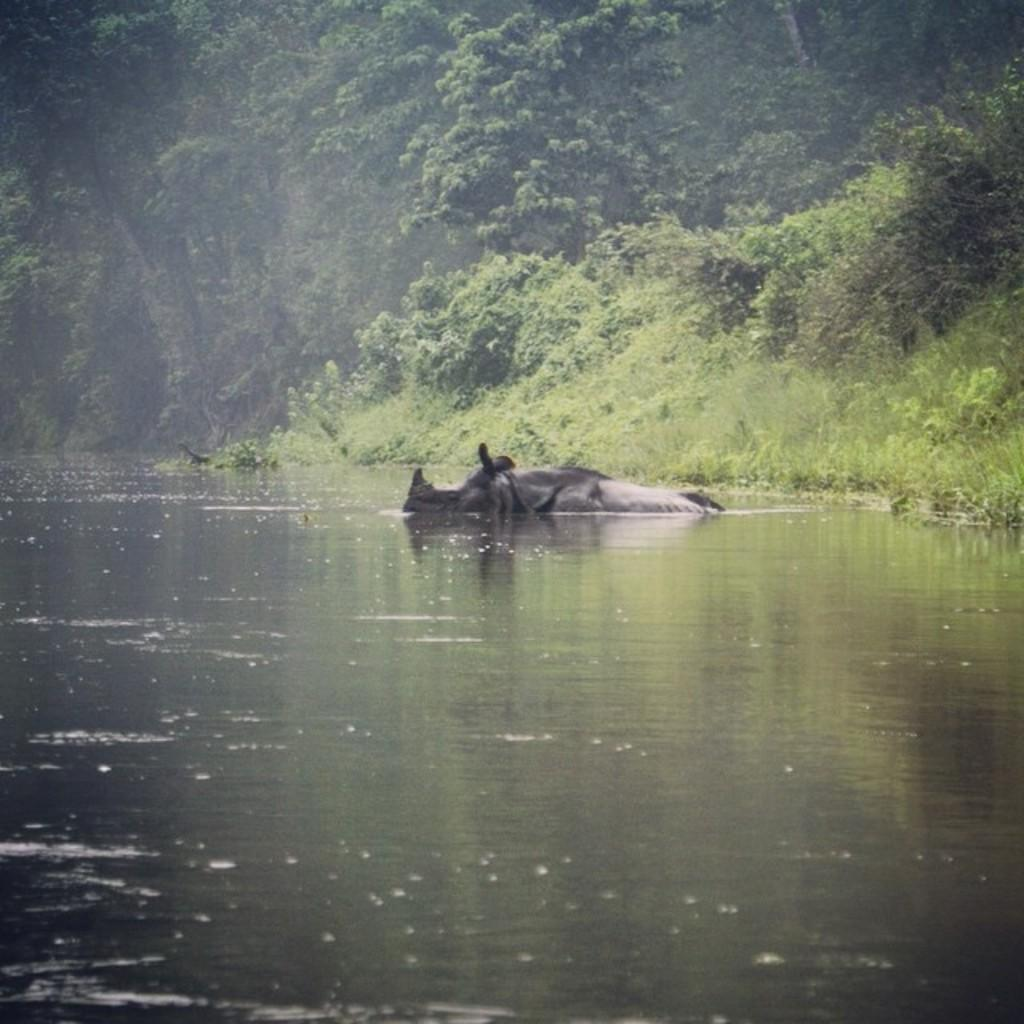What is in the foreground of the picture? There is water in the foreground of the picture. What animal can be seen in the water? A rhinoceros is present in the water. What type of vegetation is visible in the background of the image? There are plants, grass, and trees present in the background of the image. What type of stove can be seen in the background of the image? There is no stove present in the image; it features water and a rhinoceros in the foreground, with plants, grass, and trees in the background. 